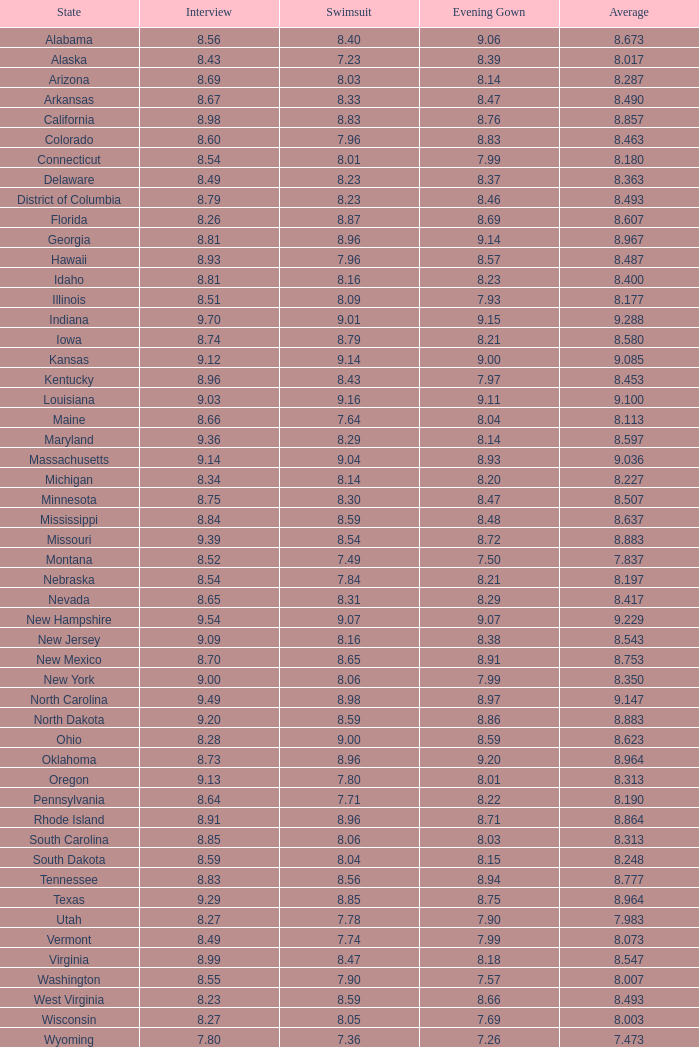0 1.0. 